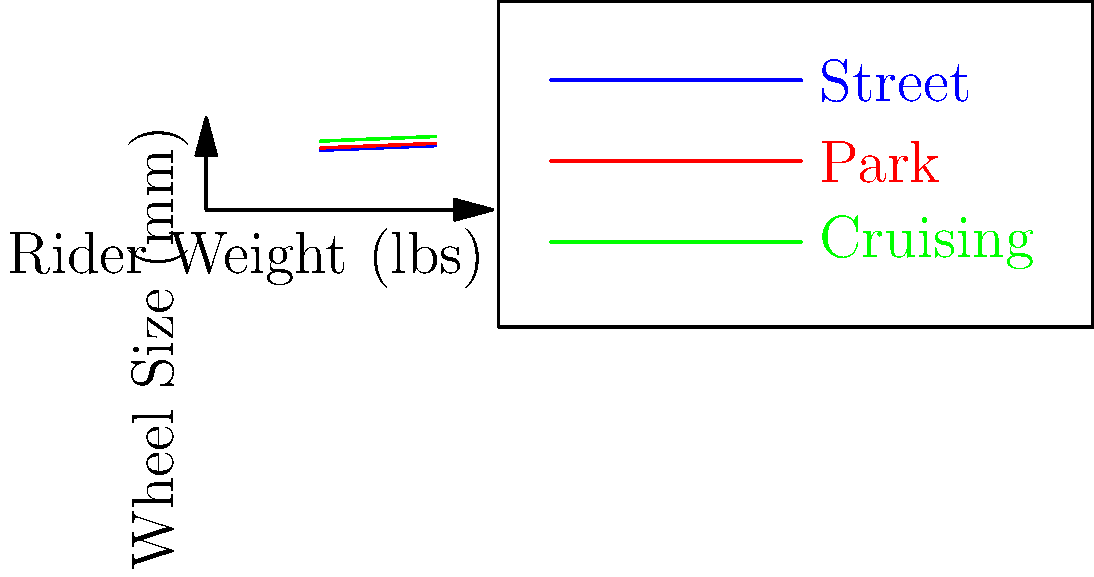Based on the graph showing the relationship between rider weight and optimal wheel size for different skateboarding terrains, what would be the recommended wheel size (in mm) for a 175 lb rider who primarily skates in parks? To determine the optimal wheel size for a 175 lb rider skating primarily in parks, we need to follow these steps:

1. Identify the line representing park terrain on the graph (red line).

2. Locate the rider's weight (175 lbs) on the x-axis.

3. From the 175 lb point, move vertically until we intersect the park terrain line.

4. From the intersection point, move horizontally to the y-axis to read the corresponding wheel size.

5. The park terrain line falls between the data points for 150 lbs and 200 lbs.

6. We can estimate the wheel size using linear interpolation:
   
   At 150 lbs, wheel size is 56 mm
   At 200 lbs, wheel size is 58 mm
   
   For 175 lbs (midpoint between 150 and 200):
   
   $$\text{Wheel size} = 56 \text{ mm} + \frac{175 - 150}{200 - 150} \times (58 - 56) \text{ mm}$$
   $$= 56 \text{ mm} + \frac{25}{50} \times 2 \text{ mm}$$
   $$= 56 \text{ mm} + 1 \text{ mm}$$
   $$= 57 \text{ mm}$$

Therefore, the recommended wheel size for a 175 lb rider skating primarily in parks is approximately 57 mm.
Answer: 57 mm 